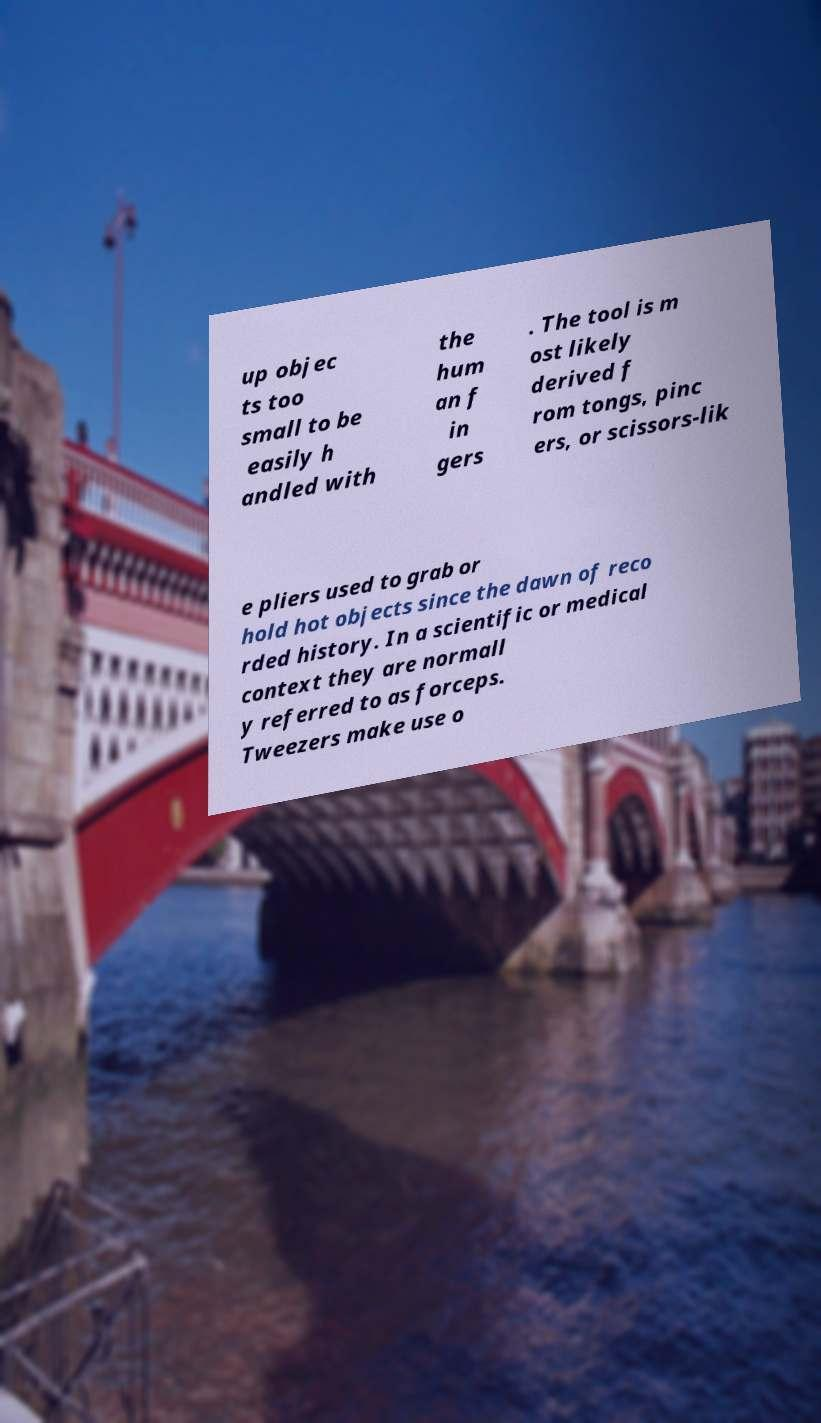I need the written content from this picture converted into text. Can you do that? up objec ts too small to be easily h andled with the hum an f in gers . The tool is m ost likely derived f rom tongs, pinc ers, or scissors-lik e pliers used to grab or hold hot objects since the dawn of reco rded history. In a scientific or medical context they are normall y referred to as forceps. Tweezers make use o 